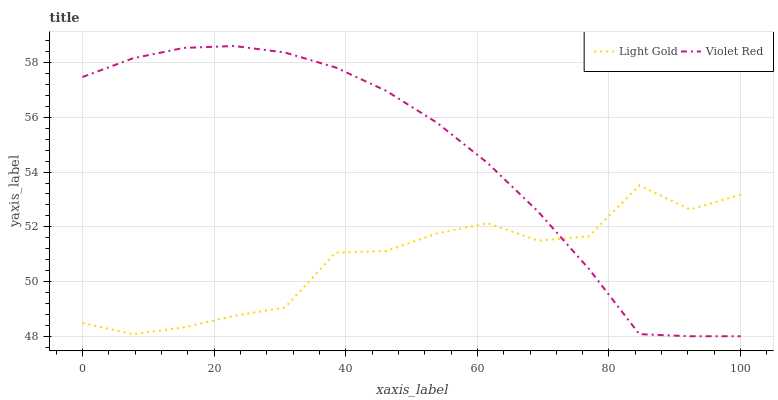Does Light Gold have the maximum area under the curve?
Answer yes or no. No. Is Light Gold the smoothest?
Answer yes or no. No. Does Light Gold have the lowest value?
Answer yes or no. No. Does Light Gold have the highest value?
Answer yes or no. No. 